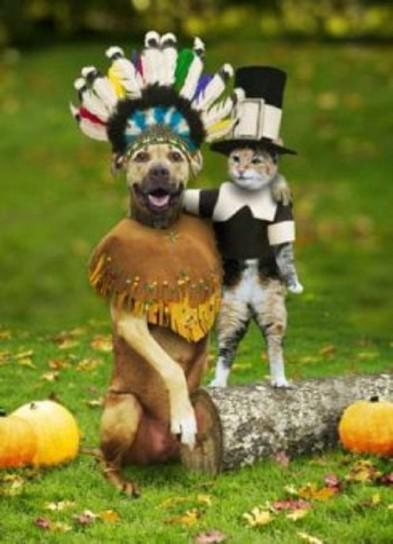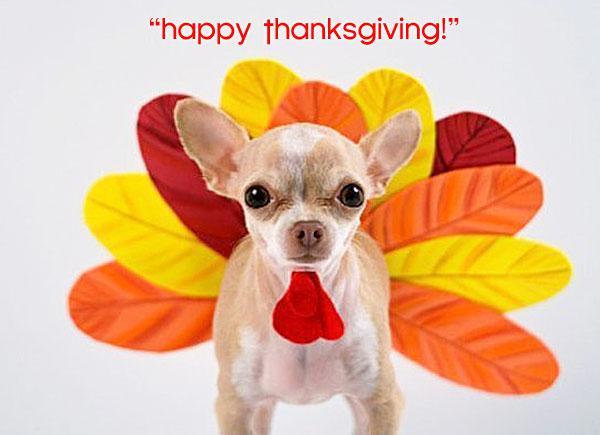The first image is the image on the left, the second image is the image on the right. Considering the images on both sides, is "There is a chihuahua that is wearing a costume in each image." valid? Answer yes or no. Yes. The first image is the image on the left, the second image is the image on the right. Evaluate the accuracy of this statement regarding the images: "The dog in the image on the left is sitting before a plate of human food.". Is it true? Answer yes or no. No. 